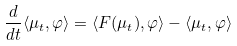Convert formula to latex. <formula><loc_0><loc_0><loc_500><loc_500>\frac { d } { d t } \langle \mu _ { t } , \varphi \rangle = \langle F ( \mu _ { t } ) , \varphi \rangle - \langle \mu _ { t } , \varphi \rangle</formula> 